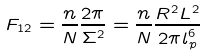<formula> <loc_0><loc_0><loc_500><loc_500>F _ { 1 2 } = \frac { n } { N } \frac { 2 \pi } { \Sigma ^ { 2 } } = \frac { n } { N } \frac { R ^ { 2 } L ^ { 2 } } { 2 \pi l ^ { 6 } _ { p } }</formula> 